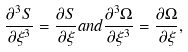Convert formula to latex. <formula><loc_0><loc_0><loc_500><loc_500>\frac { \partial ^ { 3 } S } { \partial \xi ^ { 3 } } = \frac { \partial S } { \partial \xi } a n d \frac { \partial ^ { 3 } \Omega } { \partial \xi ^ { 3 } } = \frac { \partial \Omega } { \partial \xi } ,</formula> 